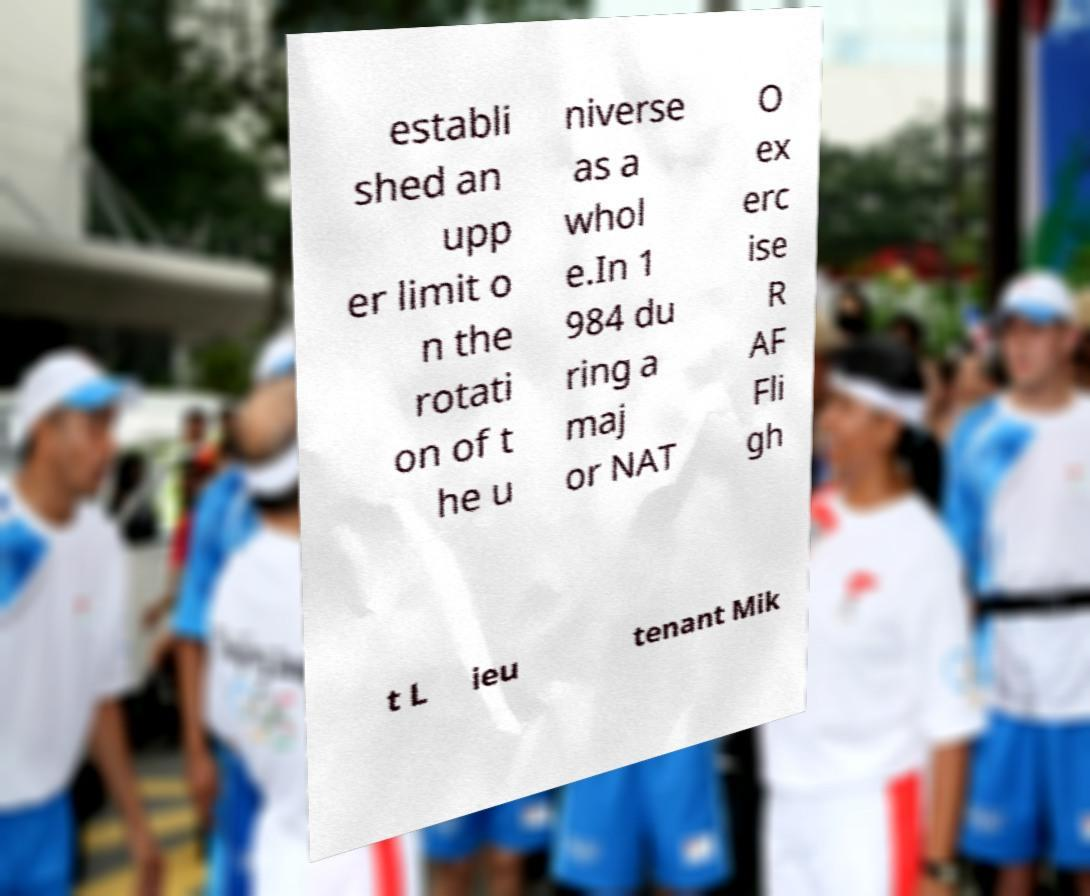Please read and relay the text visible in this image. What does it say? establi shed an upp er limit o n the rotati on of t he u niverse as a whol e.In 1 984 du ring a maj or NAT O ex erc ise R AF Fli gh t L ieu tenant Mik 